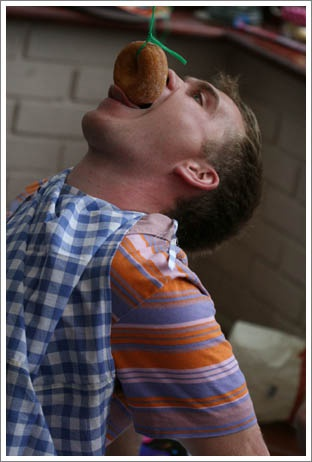Describe the objects in this image and their specific colors. I can see people in gray, black, maroon, and navy tones and donut in gray, black, and maroon tones in this image. 